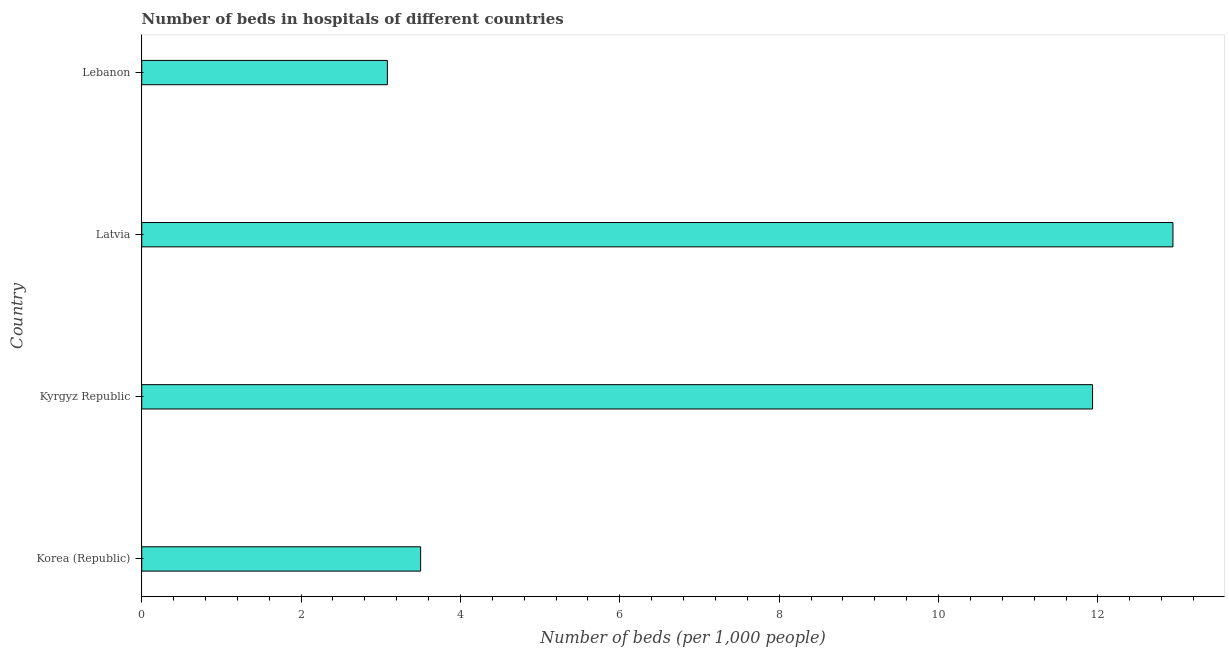What is the title of the graph?
Keep it short and to the point. Number of beds in hospitals of different countries. What is the label or title of the X-axis?
Make the answer very short. Number of beds (per 1,0 people). What is the label or title of the Y-axis?
Keep it short and to the point. Country. What is the number of hospital beds in Korea (Republic)?
Ensure brevity in your answer.  3.5. Across all countries, what is the maximum number of hospital beds?
Ensure brevity in your answer.  12.94. Across all countries, what is the minimum number of hospital beds?
Make the answer very short. 3.08. In which country was the number of hospital beds maximum?
Provide a succinct answer. Latvia. In which country was the number of hospital beds minimum?
Offer a terse response. Lebanon. What is the sum of the number of hospital beds?
Make the answer very short. 31.46. What is the difference between the number of hospital beds in Latvia and Lebanon?
Your response must be concise. 9.86. What is the average number of hospital beds per country?
Provide a succinct answer. 7.86. What is the median number of hospital beds?
Offer a terse response. 7.72. In how many countries, is the number of hospital beds greater than 8 %?
Make the answer very short. 2. What is the ratio of the number of hospital beds in Korea (Republic) to that in Latvia?
Your answer should be very brief. 0.27. Is the number of hospital beds in Kyrgyz Republic less than that in Latvia?
Provide a succinct answer. Yes. Is the difference between the number of hospital beds in Korea (Republic) and Latvia greater than the difference between any two countries?
Offer a very short reply. No. What is the difference between the highest and the lowest number of hospital beds?
Your response must be concise. 9.86. In how many countries, is the number of hospital beds greater than the average number of hospital beds taken over all countries?
Offer a very short reply. 2. How many countries are there in the graph?
Keep it short and to the point. 4. What is the difference between two consecutive major ticks on the X-axis?
Your answer should be very brief. 2. Are the values on the major ticks of X-axis written in scientific E-notation?
Make the answer very short. No. What is the Number of beds (per 1,000 people) in Kyrgyz Republic?
Your answer should be very brief. 11.93. What is the Number of beds (per 1,000 people) in Latvia?
Your answer should be very brief. 12.94. What is the Number of beds (per 1,000 people) in Lebanon?
Your response must be concise. 3.08. What is the difference between the Number of beds (per 1,000 people) in Korea (Republic) and Kyrgyz Republic?
Your response must be concise. -8.43. What is the difference between the Number of beds (per 1,000 people) in Korea (Republic) and Latvia?
Provide a short and direct response. -9.44. What is the difference between the Number of beds (per 1,000 people) in Korea (Republic) and Lebanon?
Provide a succinct answer. 0.42. What is the difference between the Number of beds (per 1,000 people) in Kyrgyz Republic and Latvia?
Ensure brevity in your answer.  -1.01. What is the difference between the Number of beds (per 1,000 people) in Kyrgyz Republic and Lebanon?
Your response must be concise. 8.85. What is the difference between the Number of beds (per 1,000 people) in Latvia and Lebanon?
Keep it short and to the point. 9.86. What is the ratio of the Number of beds (per 1,000 people) in Korea (Republic) to that in Kyrgyz Republic?
Give a very brief answer. 0.29. What is the ratio of the Number of beds (per 1,000 people) in Korea (Republic) to that in Latvia?
Provide a succinct answer. 0.27. What is the ratio of the Number of beds (per 1,000 people) in Korea (Republic) to that in Lebanon?
Provide a succinct answer. 1.14. What is the ratio of the Number of beds (per 1,000 people) in Kyrgyz Republic to that in Latvia?
Offer a terse response. 0.92. What is the ratio of the Number of beds (per 1,000 people) in Kyrgyz Republic to that in Lebanon?
Offer a terse response. 3.87. What is the ratio of the Number of beds (per 1,000 people) in Latvia to that in Lebanon?
Your response must be concise. 4.2. 